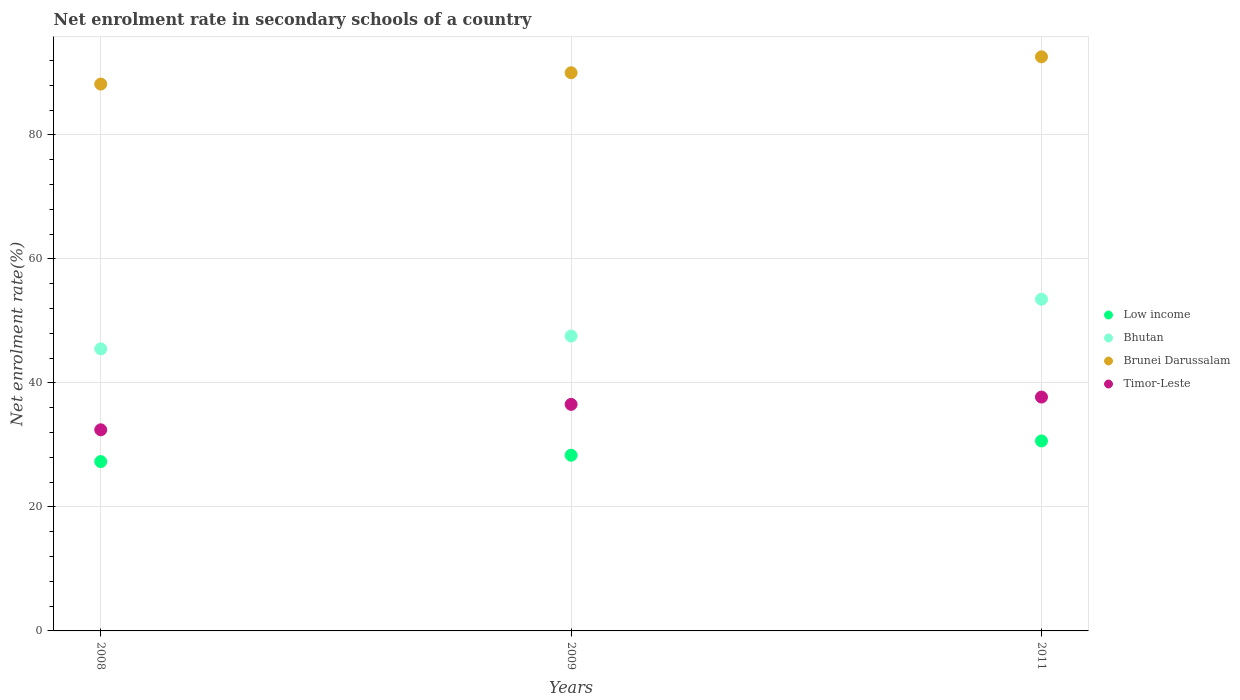Is the number of dotlines equal to the number of legend labels?
Your response must be concise. Yes. What is the net enrolment rate in secondary schools in Low income in 2011?
Provide a short and direct response. 30.64. Across all years, what is the maximum net enrolment rate in secondary schools in Low income?
Your response must be concise. 30.64. Across all years, what is the minimum net enrolment rate in secondary schools in Low income?
Your answer should be very brief. 27.31. In which year was the net enrolment rate in secondary schools in Low income maximum?
Make the answer very short. 2011. In which year was the net enrolment rate in secondary schools in Bhutan minimum?
Offer a terse response. 2008. What is the total net enrolment rate in secondary schools in Timor-Leste in the graph?
Make the answer very short. 106.69. What is the difference between the net enrolment rate in secondary schools in Bhutan in 2008 and that in 2011?
Your answer should be very brief. -8. What is the difference between the net enrolment rate in secondary schools in Bhutan in 2011 and the net enrolment rate in secondary schools in Low income in 2009?
Your response must be concise. 25.16. What is the average net enrolment rate in secondary schools in Timor-Leste per year?
Make the answer very short. 35.56. In the year 2009, what is the difference between the net enrolment rate in secondary schools in Low income and net enrolment rate in secondary schools in Brunei Darussalam?
Offer a very short reply. -61.69. What is the ratio of the net enrolment rate in secondary schools in Bhutan in 2008 to that in 2009?
Your answer should be very brief. 0.96. Is the net enrolment rate in secondary schools in Bhutan in 2009 less than that in 2011?
Provide a short and direct response. Yes. What is the difference between the highest and the second highest net enrolment rate in secondary schools in Bhutan?
Offer a terse response. 5.94. What is the difference between the highest and the lowest net enrolment rate in secondary schools in Brunei Darussalam?
Ensure brevity in your answer.  4.4. In how many years, is the net enrolment rate in secondary schools in Low income greater than the average net enrolment rate in secondary schools in Low income taken over all years?
Keep it short and to the point. 1. Is the sum of the net enrolment rate in secondary schools in Brunei Darussalam in 2009 and 2011 greater than the maximum net enrolment rate in secondary schools in Low income across all years?
Your answer should be very brief. Yes. Is it the case that in every year, the sum of the net enrolment rate in secondary schools in Low income and net enrolment rate in secondary schools in Brunei Darussalam  is greater than the net enrolment rate in secondary schools in Timor-Leste?
Your answer should be compact. Yes. Does the net enrolment rate in secondary schools in Timor-Leste monotonically increase over the years?
Provide a short and direct response. Yes. Is the net enrolment rate in secondary schools in Low income strictly greater than the net enrolment rate in secondary schools in Timor-Leste over the years?
Give a very brief answer. No. How many dotlines are there?
Keep it short and to the point. 4. Are the values on the major ticks of Y-axis written in scientific E-notation?
Keep it short and to the point. No. Does the graph contain any zero values?
Offer a very short reply. No. What is the title of the graph?
Provide a short and direct response. Net enrolment rate in secondary schools of a country. What is the label or title of the Y-axis?
Your answer should be very brief. Net enrolment rate(%). What is the Net enrolment rate(%) in Low income in 2008?
Make the answer very short. 27.31. What is the Net enrolment rate(%) in Bhutan in 2008?
Your response must be concise. 45.49. What is the Net enrolment rate(%) in Brunei Darussalam in 2008?
Keep it short and to the point. 88.19. What is the Net enrolment rate(%) of Timor-Leste in 2008?
Your answer should be compact. 32.44. What is the Net enrolment rate(%) of Low income in 2009?
Your response must be concise. 28.33. What is the Net enrolment rate(%) of Bhutan in 2009?
Your response must be concise. 47.56. What is the Net enrolment rate(%) in Brunei Darussalam in 2009?
Your answer should be very brief. 90.02. What is the Net enrolment rate(%) of Timor-Leste in 2009?
Give a very brief answer. 36.54. What is the Net enrolment rate(%) of Low income in 2011?
Provide a succinct answer. 30.64. What is the Net enrolment rate(%) of Bhutan in 2011?
Your answer should be very brief. 53.49. What is the Net enrolment rate(%) of Brunei Darussalam in 2011?
Your answer should be compact. 92.59. What is the Net enrolment rate(%) in Timor-Leste in 2011?
Offer a very short reply. 37.71. Across all years, what is the maximum Net enrolment rate(%) in Low income?
Offer a very short reply. 30.64. Across all years, what is the maximum Net enrolment rate(%) of Bhutan?
Provide a short and direct response. 53.49. Across all years, what is the maximum Net enrolment rate(%) in Brunei Darussalam?
Offer a very short reply. 92.59. Across all years, what is the maximum Net enrolment rate(%) of Timor-Leste?
Your answer should be compact. 37.71. Across all years, what is the minimum Net enrolment rate(%) in Low income?
Your response must be concise. 27.31. Across all years, what is the minimum Net enrolment rate(%) in Bhutan?
Your response must be concise. 45.49. Across all years, what is the minimum Net enrolment rate(%) in Brunei Darussalam?
Offer a terse response. 88.19. Across all years, what is the minimum Net enrolment rate(%) in Timor-Leste?
Give a very brief answer. 32.44. What is the total Net enrolment rate(%) of Low income in the graph?
Your answer should be very brief. 86.28. What is the total Net enrolment rate(%) of Bhutan in the graph?
Give a very brief answer. 146.54. What is the total Net enrolment rate(%) of Brunei Darussalam in the graph?
Give a very brief answer. 270.8. What is the total Net enrolment rate(%) in Timor-Leste in the graph?
Provide a succinct answer. 106.69. What is the difference between the Net enrolment rate(%) of Low income in 2008 and that in 2009?
Provide a succinct answer. -1.02. What is the difference between the Net enrolment rate(%) of Bhutan in 2008 and that in 2009?
Your answer should be compact. -2.07. What is the difference between the Net enrolment rate(%) in Brunei Darussalam in 2008 and that in 2009?
Provide a succinct answer. -1.83. What is the difference between the Net enrolment rate(%) in Timor-Leste in 2008 and that in 2009?
Offer a very short reply. -4.1. What is the difference between the Net enrolment rate(%) in Low income in 2008 and that in 2011?
Your answer should be compact. -3.33. What is the difference between the Net enrolment rate(%) of Bhutan in 2008 and that in 2011?
Keep it short and to the point. -8. What is the difference between the Net enrolment rate(%) of Brunei Darussalam in 2008 and that in 2011?
Your answer should be very brief. -4.4. What is the difference between the Net enrolment rate(%) of Timor-Leste in 2008 and that in 2011?
Ensure brevity in your answer.  -5.28. What is the difference between the Net enrolment rate(%) of Low income in 2009 and that in 2011?
Offer a very short reply. -2.3. What is the difference between the Net enrolment rate(%) in Bhutan in 2009 and that in 2011?
Give a very brief answer. -5.94. What is the difference between the Net enrolment rate(%) of Brunei Darussalam in 2009 and that in 2011?
Keep it short and to the point. -2.57. What is the difference between the Net enrolment rate(%) in Timor-Leste in 2009 and that in 2011?
Provide a short and direct response. -1.18. What is the difference between the Net enrolment rate(%) of Low income in 2008 and the Net enrolment rate(%) of Bhutan in 2009?
Your answer should be compact. -20.24. What is the difference between the Net enrolment rate(%) of Low income in 2008 and the Net enrolment rate(%) of Brunei Darussalam in 2009?
Ensure brevity in your answer.  -62.71. What is the difference between the Net enrolment rate(%) in Low income in 2008 and the Net enrolment rate(%) in Timor-Leste in 2009?
Offer a terse response. -9.22. What is the difference between the Net enrolment rate(%) in Bhutan in 2008 and the Net enrolment rate(%) in Brunei Darussalam in 2009?
Offer a terse response. -44.53. What is the difference between the Net enrolment rate(%) of Bhutan in 2008 and the Net enrolment rate(%) of Timor-Leste in 2009?
Offer a very short reply. 8.95. What is the difference between the Net enrolment rate(%) of Brunei Darussalam in 2008 and the Net enrolment rate(%) of Timor-Leste in 2009?
Provide a short and direct response. 51.66. What is the difference between the Net enrolment rate(%) of Low income in 2008 and the Net enrolment rate(%) of Bhutan in 2011?
Keep it short and to the point. -26.18. What is the difference between the Net enrolment rate(%) in Low income in 2008 and the Net enrolment rate(%) in Brunei Darussalam in 2011?
Keep it short and to the point. -65.28. What is the difference between the Net enrolment rate(%) of Low income in 2008 and the Net enrolment rate(%) of Timor-Leste in 2011?
Offer a very short reply. -10.4. What is the difference between the Net enrolment rate(%) of Bhutan in 2008 and the Net enrolment rate(%) of Brunei Darussalam in 2011?
Your answer should be compact. -47.1. What is the difference between the Net enrolment rate(%) of Bhutan in 2008 and the Net enrolment rate(%) of Timor-Leste in 2011?
Give a very brief answer. 7.78. What is the difference between the Net enrolment rate(%) in Brunei Darussalam in 2008 and the Net enrolment rate(%) in Timor-Leste in 2011?
Your answer should be very brief. 50.48. What is the difference between the Net enrolment rate(%) in Low income in 2009 and the Net enrolment rate(%) in Bhutan in 2011?
Make the answer very short. -25.16. What is the difference between the Net enrolment rate(%) of Low income in 2009 and the Net enrolment rate(%) of Brunei Darussalam in 2011?
Your answer should be compact. -64.25. What is the difference between the Net enrolment rate(%) in Low income in 2009 and the Net enrolment rate(%) in Timor-Leste in 2011?
Your response must be concise. -9.38. What is the difference between the Net enrolment rate(%) in Bhutan in 2009 and the Net enrolment rate(%) in Brunei Darussalam in 2011?
Provide a succinct answer. -45.03. What is the difference between the Net enrolment rate(%) of Bhutan in 2009 and the Net enrolment rate(%) of Timor-Leste in 2011?
Offer a terse response. 9.84. What is the difference between the Net enrolment rate(%) of Brunei Darussalam in 2009 and the Net enrolment rate(%) of Timor-Leste in 2011?
Give a very brief answer. 52.31. What is the average Net enrolment rate(%) of Low income per year?
Provide a short and direct response. 28.76. What is the average Net enrolment rate(%) of Bhutan per year?
Give a very brief answer. 48.85. What is the average Net enrolment rate(%) in Brunei Darussalam per year?
Offer a very short reply. 90.27. What is the average Net enrolment rate(%) of Timor-Leste per year?
Provide a short and direct response. 35.56. In the year 2008, what is the difference between the Net enrolment rate(%) in Low income and Net enrolment rate(%) in Bhutan?
Provide a succinct answer. -18.18. In the year 2008, what is the difference between the Net enrolment rate(%) of Low income and Net enrolment rate(%) of Brunei Darussalam?
Your response must be concise. -60.88. In the year 2008, what is the difference between the Net enrolment rate(%) of Low income and Net enrolment rate(%) of Timor-Leste?
Your answer should be very brief. -5.12. In the year 2008, what is the difference between the Net enrolment rate(%) of Bhutan and Net enrolment rate(%) of Brunei Darussalam?
Provide a short and direct response. -42.7. In the year 2008, what is the difference between the Net enrolment rate(%) of Bhutan and Net enrolment rate(%) of Timor-Leste?
Provide a succinct answer. 13.05. In the year 2008, what is the difference between the Net enrolment rate(%) in Brunei Darussalam and Net enrolment rate(%) in Timor-Leste?
Ensure brevity in your answer.  55.76. In the year 2009, what is the difference between the Net enrolment rate(%) in Low income and Net enrolment rate(%) in Bhutan?
Your answer should be compact. -19.22. In the year 2009, what is the difference between the Net enrolment rate(%) of Low income and Net enrolment rate(%) of Brunei Darussalam?
Your answer should be compact. -61.69. In the year 2009, what is the difference between the Net enrolment rate(%) in Low income and Net enrolment rate(%) in Timor-Leste?
Give a very brief answer. -8.2. In the year 2009, what is the difference between the Net enrolment rate(%) in Bhutan and Net enrolment rate(%) in Brunei Darussalam?
Your answer should be compact. -42.46. In the year 2009, what is the difference between the Net enrolment rate(%) in Bhutan and Net enrolment rate(%) in Timor-Leste?
Your answer should be very brief. 11.02. In the year 2009, what is the difference between the Net enrolment rate(%) of Brunei Darussalam and Net enrolment rate(%) of Timor-Leste?
Offer a terse response. 53.48. In the year 2011, what is the difference between the Net enrolment rate(%) of Low income and Net enrolment rate(%) of Bhutan?
Offer a terse response. -22.86. In the year 2011, what is the difference between the Net enrolment rate(%) of Low income and Net enrolment rate(%) of Brunei Darussalam?
Ensure brevity in your answer.  -61.95. In the year 2011, what is the difference between the Net enrolment rate(%) of Low income and Net enrolment rate(%) of Timor-Leste?
Your answer should be very brief. -7.08. In the year 2011, what is the difference between the Net enrolment rate(%) in Bhutan and Net enrolment rate(%) in Brunei Darussalam?
Offer a very short reply. -39.1. In the year 2011, what is the difference between the Net enrolment rate(%) of Bhutan and Net enrolment rate(%) of Timor-Leste?
Provide a short and direct response. 15.78. In the year 2011, what is the difference between the Net enrolment rate(%) of Brunei Darussalam and Net enrolment rate(%) of Timor-Leste?
Ensure brevity in your answer.  54.88. What is the ratio of the Net enrolment rate(%) of Low income in 2008 to that in 2009?
Keep it short and to the point. 0.96. What is the ratio of the Net enrolment rate(%) in Bhutan in 2008 to that in 2009?
Give a very brief answer. 0.96. What is the ratio of the Net enrolment rate(%) of Brunei Darussalam in 2008 to that in 2009?
Your response must be concise. 0.98. What is the ratio of the Net enrolment rate(%) of Timor-Leste in 2008 to that in 2009?
Provide a short and direct response. 0.89. What is the ratio of the Net enrolment rate(%) of Low income in 2008 to that in 2011?
Your response must be concise. 0.89. What is the ratio of the Net enrolment rate(%) of Bhutan in 2008 to that in 2011?
Keep it short and to the point. 0.85. What is the ratio of the Net enrolment rate(%) in Brunei Darussalam in 2008 to that in 2011?
Your answer should be compact. 0.95. What is the ratio of the Net enrolment rate(%) in Timor-Leste in 2008 to that in 2011?
Your response must be concise. 0.86. What is the ratio of the Net enrolment rate(%) in Low income in 2009 to that in 2011?
Provide a short and direct response. 0.92. What is the ratio of the Net enrolment rate(%) in Bhutan in 2009 to that in 2011?
Your answer should be very brief. 0.89. What is the ratio of the Net enrolment rate(%) in Brunei Darussalam in 2009 to that in 2011?
Offer a very short reply. 0.97. What is the ratio of the Net enrolment rate(%) in Timor-Leste in 2009 to that in 2011?
Your answer should be very brief. 0.97. What is the difference between the highest and the second highest Net enrolment rate(%) in Low income?
Offer a very short reply. 2.3. What is the difference between the highest and the second highest Net enrolment rate(%) of Bhutan?
Your answer should be very brief. 5.94. What is the difference between the highest and the second highest Net enrolment rate(%) of Brunei Darussalam?
Give a very brief answer. 2.57. What is the difference between the highest and the second highest Net enrolment rate(%) of Timor-Leste?
Your response must be concise. 1.18. What is the difference between the highest and the lowest Net enrolment rate(%) in Low income?
Provide a succinct answer. 3.33. What is the difference between the highest and the lowest Net enrolment rate(%) in Bhutan?
Your answer should be very brief. 8. What is the difference between the highest and the lowest Net enrolment rate(%) of Brunei Darussalam?
Provide a short and direct response. 4.4. What is the difference between the highest and the lowest Net enrolment rate(%) of Timor-Leste?
Ensure brevity in your answer.  5.28. 